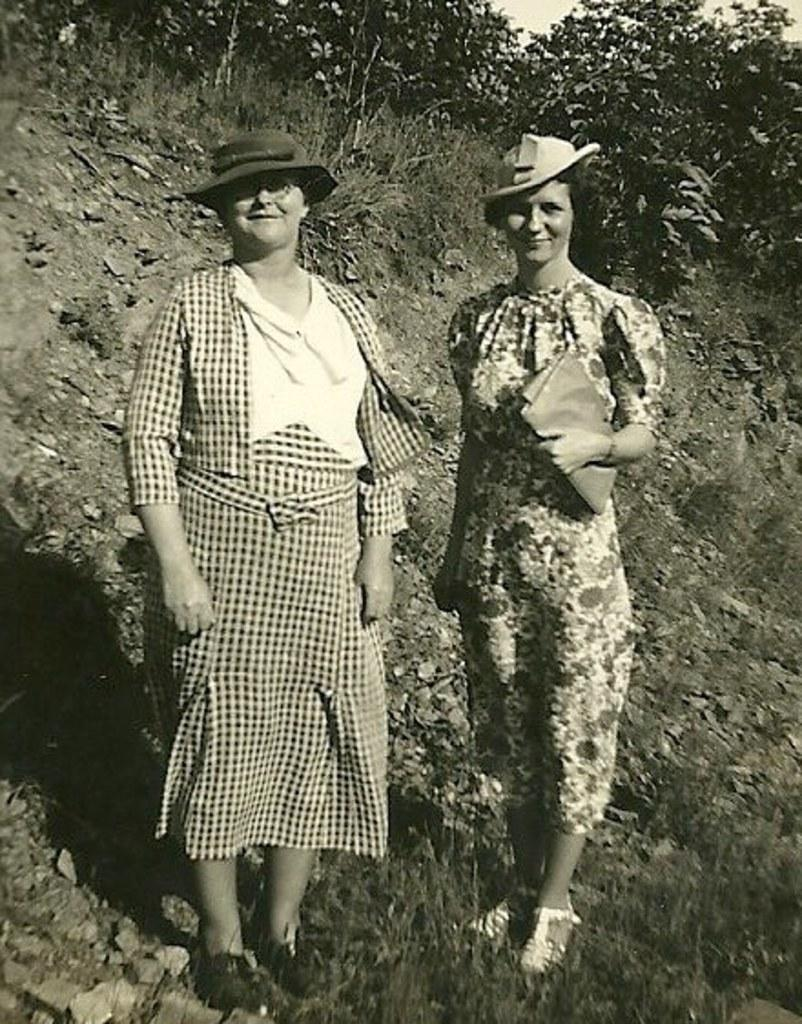How many women are in the image? There are two women in the image. What are the women wearing on their heads? The women are wearing hats. What position are the women in? The women are standing. What type of vegetation can be seen in the background of the image? There are trees in the background of the image. What is visible on the ground in the image? There is grass visible in the image. What is visible at the top of the image? The sky is visible at the top of the image. What type of metal object can be seen being used by the women in the image? There is no metal object being used by the women in the image. What color is the chalk that the women are drawing with in the image? There is no chalk or drawing activity present in the image. 